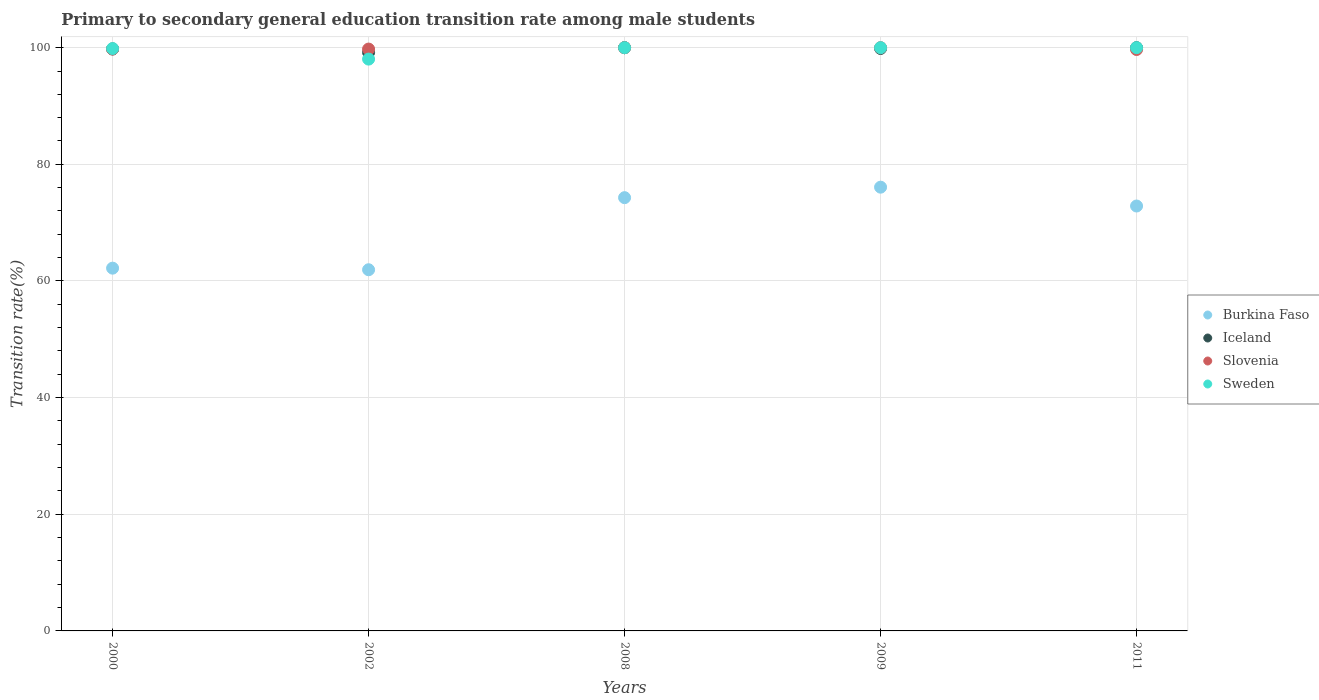How many different coloured dotlines are there?
Offer a very short reply. 4. What is the transition rate in Slovenia in 2002?
Give a very brief answer. 99.76. Across all years, what is the minimum transition rate in Iceland?
Make the answer very short. 99.18. In which year was the transition rate in Sweden maximum?
Give a very brief answer. 2008. What is the total transition rate in Burkina Faso in the graph?
Offer a terse response. 347.34. What is the difference between the transition rate in Slovenia in 2000 and that in 2002?
Offer a terse response. 0.01. What is the difference between the transition rate in Iceland in 2000 and the transition rate in Slovenia in 2008?
Offer a terse response. -0.23. What is the average transition rate in Burkina Faso per year?
Your answer should be very brief. 69.47. In the year 2008, what is the difference between the transition rate in Slovenia and transition rate in Sweden?
Ensure brevity in your answer.  0. What is the ratio of the transition rate in Sweden in 2000 to that in 2008?
Provide a short and direct response. 1. Is the difference between the transition rate in Slovenia in 2002 and 2011 greater than the difference between the transition rate in Sweden in 2002 and 2011?
Ensure brevity in your answer.  Yes. What is the difference between the highest and the second highest transition rate in Burkina Faso?
Ensure brevity in your answer.  1.8. What is the difference between the highest and the lowest transition rate in Sweden?
Your response must be concise. 1.96. Is the sum of the transition rate in Burkina Faso in 2000 and 2002 greater than the maximum transition rate in Sweden across all years?
Your response must be concise. Yes. Is it the case that in every year, the sum of the transition rate in Burkina Faso and transition rate in Slovenia  is greater than the transition rate in Iceland?
Ensure brevity in your answer.  Yes. Is the transition rate in Burkina Faso strictly greater than the transition rate in Sweden over the years?
Offer a very short reply. No. What is the difference between two consecutive major ticks on the Y-axis?
Provide a short and direct response. 20. Where does the legend appear in the graph?
Your answer should be very brief. Center right. How many legend labels are there?
Offer a terse response. 4. How are the legend labels stacked?
Offer a very short reply. Vertical. What is the title of the graph?
Your response must be concise. Primary to secondary general education transition rate among male students. What is the label or title of the X-axis?
Ensure brevity in your answer.  Years. What is the label or title of the Y-axis?
Offer a terse response. Transition rate(%). What is the Transition rate(%) of Burkina Faso in 2000?
Your answer should be compact. 62.2. What is the Transition rate(%) of Iceland in 2000?
Offer a very short reply. 99.77. What is the Transition rate(%) of Slovenia in 2000?
Offer a very short reply. 99.77. What is the Transition rate(%) of Sweden in 2000?
Make the answer very short. 99.85. What is the Transition rate(%) in Burkina Faso in 2002?
Your answer should be compact. 61.93. What is the Transition rate(%) in Iceland in 2002?
Make the answer very short. 99.18. What is the Transition rate(%) in Slovenia in 2002?
Ensure brevity in your answer.  99.76. What is the Transition rate(%) of Sweden in 2002?
Make the answer very short. 98.04. What is the Transition rate(%) of Burkina Faso in 2008?
Give a very brief answer. 74.28. What is the Transition rate(%) of Iceland in 2008?
Provide a short and direct response. 100. What is the Transition rate(%) in Sweden in 2008?
Keep it short and to the point. 100. What is the Transition rate(%) of Burkina Faso in 2009?
Your answer should be very brief. 76.08. What is the Transition rate(%) of Iceland in 2009?
Offer a terse response. 99.86. What is the Transition rate(%) of Slovenia in 2009?
Give a very brief answer. 100. What is the Transition rate(%) in Sweden in 2009?
Your answer should be very brief. 100. What is the Transition rate(%) in Burkina Faso in 2011?
Provide a short and direct response. 72.85. What is the Transition rate(%) in Slovenia in 2011?
Make the answer very short. 99.69. What is the Transition rate(%) of Sweden in 2011?
Provide a short and direct response. 100. Across all years, what is the maximum Transition rate(%) of Burkina Faso?
Give a very brief answer. 76.08. Across all years, what is the maximum Transition rate(%) of Iceland?
Keep it short and to the point. 100. Across all years, what is the maximum Transition rate(%) in Slovenia?
Give a very brief answer. 100. Across all years, what is the maximum Transition rate(%) in Sweden?
Give a very brief answer. 100. Across all years, what is the minimum Transition rate(%) of Burkina Faso?
Make the answer very short. 61.93. Across all years, what is the minimum Transition rate(%) of Iceland?
Provide a succinct answer. 99.18. Across all years, what is the minimum Transition rate(%) of Slovenia?
Offer a very short reply. 99.69. Across all years, what is the minimum Transition rate(%) in Sweden?
Keep it short and to the point. 98.04. What is the total Transition rate(%) in Burkina Faso in the graph?
Offer a very short reply. 347.34. What is the total Transition rate(%) in Iceland in the graph?
Your response must be concise. 498.81. What is the total Transition rate(%) of Slovenia in the graph?
Keep it short and to the point. 499.22. What is the total Transition rate(%) in Sweden in the graph?
Provide a short and direct response. 497.89. What is the difference between the Transition rate(%) in Burkina Faso in 2000 and that in 2002?
Make the answer very short. 0.27. What is the difference between the Transition rate(%) in Iceland in 2000 and that in 2002?
Your answer should be very brief. 0.59. What is the difference between the Transition rate(%) in Slovenia in 2000 and that in 2002?
Keep it short and to the point. 0.01. What is the difference between the Transition rate(%) in Sweden in 2000 and that in 2002?
Your answer should be compact. 1.81. What is the difference between the Transition rate(%) of Burkina Faso in 2000 and that in 2008?
Keep it short and to the point. -12.09. What is the difference between the Transition rate(%) of Iceland in 2000 and that in 2008?
Give a very brief answer. -0.23. What is the difference between the Transition rate(%) in Slovenia in 2000 and that in 2008?
Make the answer very short. -0.23. What is the difference between the Transition rate(%) of Sweden in 2000 and that in 2008?
Provide a succinct answer. -0.15. What is the difference between the Transition rate(%) of Burkina Faso in 2000 and that in 2009?
Offer a terse response. -13.88. What is the difference between the Transition rate(%) in Iceland in 2000 and that in 2009?
Make the answer very short. -0.09. What is the difference between the Transition rate(%) in Slovenia in 2000 and that in 2009?
Give a very brief answer. -0.23. What is the difference between the Transition rate(%) in Sweden in 2000 and that in 2009?
Make the answer very short. -0.15. What is the difference between the Transition rate(%) in Burkina Faso in 2000 and that in 2011?
Offer a very short reply. -10.65. What is the difference between the Transition rate(%) of Iceland in 2000 and that in 2011?
Ensure brevity in your answer.  -0.23. What is the difference between the Transition rate(%) in Slovenia in 2000 and that in 2011?
Offer a terse response. 0.09. What is the difference between the Transition rate(%) in Sweden in 2000 and that in 2011?
Offer a terse response. -0.15. What is the difference between the Transition rate(%) of Burkina Faso in 2002 and that in 2008?
Make the answer very short. -12.36. What is the difference between the Transition rate(%) of Iceland in 2002 and that in 2008?
Keep it short and to the point. -0.82. What is the difference between the Transition rate(%) in Slovenia in 2002 and that in 2008?
Offer a terse response. -0.24. What is the difference between the Transition rate(%) of Sweden in 2002 and that in 2008?
Offer a very short reply. -1.96. What is the difference between the Transition rate(%) in Burkina Faso in 2002 and that in 2009?
Offer a very short reply. -14.16. What is the difference between the Transition rate(%) of Iceland in 2002 and that in 2009?
Offer a terse response. -0.68. What is the difference between the Transition rate(%) of Slovenia in 2002 and that in 2009?
Your answer should be very brief. -0.24. What is the difference between the Transition rate(%) in Sweden in 2002 and that in 2009?
Your answer should be compact. -1.96. What is the difference between the Transition rate(%) of Burkina Faso in 2002 and that in 2011?
Your answer should be very brief. -10.93. What is the difference between the Transition rate(%) in Iceland in 2002 and that in 2011?
Ensure brevity in your answer.  -0.82. What is the difference between the Transition rate(%) of Slovenia in 2002 and that in 2011?
Provide a succinct answer. 0.07. What is the difference between the Transition rate(%) of Sweden in 2002 and that in 2011?
Your answer should be compact. -1.96. What is the difference between the Transition rate(%) in Burkina Faso in 2008 and that in 2009?
Keep it short and to the point. -1.8. What is the difference between the Transition rate(%) in Iceland in 2008 and that in 2009?
Ensure brevity in your answer.  0.14. What is the difference between the Transition rate(%) in Slovenia in 2008 and that in 2009?
Your answer should be very brief. 0. What is the difference between the Transition rate(%) of Sweden in 2008 and that in 2009?
Ensure brevity in your answer.  0. What is the difference between the Transition rate(%) in Burkina Faso in 2008 and that in 2011?
Provide a short and direct response. 1.43. What is the difference between the Transition rate(%) in Iceland in 2008 and that in 2011?
Your response must be concise. 0. What is the difference between the Transition rate(%) of Slovenia in 2008 and that in 2011?
Ensure brevity in your answer.  0.31. What is the difference between the Transition rate(%) in Burkina Faso in 2009 and that in 2011?
Give a very brief answer. 3.23. What is the difference between the Transition rate(%) in Iceland in 2009 and that in 2011?
Offer a terse response. -0.14. What is the difference between the Transition rate(%) of Slovenia in 2009 and that in 2011?
Your response must be concise. 0.31. What is the difference between the Transition rate(%) in Burkina Faso in 2000 and the Transition rate(%) in Iceland in 2002?
Give a very brief answer. -36.98. What is the difference between the Transition rate(%) of Burkina Faso in 2000 and the Transition rate(%) of Slovenia in 2002?
Provide a short and direct response. -37.56. What is the difference between the Transition rate(%) in Burkina Faso in 2000 and the Transition rate(%) in Sweden in 2002?
Make the answer very short. -35.84. What is the difference between the Transition rate(%) in Iceland in 2000 and the Transition rate(%) in Slovenia in 2002?
Your answer should be very brief. 0.01. What is the difference between the Transition rate(%) in Iceland in 2000 and the Transition rate(%) in Sweden in 2002?
Keep it short and to the point. 1.73. What is the difference between the Transition rate(%) in Slovenia in 2000 and the Transition rate(%) in Sweden in 2002?
Provide a short and direct response. 1.73. What is the difference between the Transition rate(%) of Burkina Faso in 2000 and the Transition rate(%) of Iceland in 2008?
Make the answer very short. -37.8. What is the difference between the Transition rate(%) in Burkina Faso in 2000 and the Transition rate(%) in Slovenia in 2008?
Offer a terse response. -37.8. What is the difference between the Transition rate(%) in Burkina Faso in 2000 and the Transition rate(%) in Sweden in 2008?
Offer a very short reply. -37.8. What is the difference between the Transition rate(%) in Iceland in 2000 and the Transition rate(%) in Slovenia in 2008?
Your answer should be very brief. -0.23. What is the difference between the Transition rate(%) of Iceland in 2000 and the Transition rate(%) of Sweden in 2008?
Keep it short and to the point. -0.23. What is the difference between the Transition rate(%) in Slovenia in 2000 and the Transition rate(%) in Sweden in 2008?
Keep it short and to the point. -0.23. What is the difference between the Transition rate(%) in Burkina Faso in 2000 and the Transition rate(%) in Iceland in 2009?
Provide a succinct answer. -37.66. What is the difference between the Transition rate(%) of Burkina Faso in 2000 and the Transition rate(%) of Slovenia in 2009?
Provide a short and direct response. -37.8. What is the difference between the Transition rate(%) in Burkina Faso in 2000 and the Transition rate(%) in Sweden in 2009?
Provide a succinct answer. -37.8. What is the difference between the Transition rate(%) in Iceland in 2000 and the Transition rate(%) in Slovenia in 2009?
Provide a short and direct response. -0.23. What is the difference between the Transition rate(%) in Iceland in 2000 and the Transition rate(%) in Sweden in 2009?
Provide a succinct answer. -0.23. What is the difference between the Transition rate(%) in Slovenia in 2000 and the Transition rate(%) in Sweden in 2009?
Keep it short and to the point. -0.23. What is the difference between the Transition rate(%) in Burkina Faso in 2000 and the Transition rate(%) in Iceland in 2011?
Your response must be concise. -37.8. What is the difference between the Transition rate(%) of Burkina Faso in 2000 and the Transition rate(%) of Slovenia in 2011?
Your response must be concise. -37.49. What is the difference between the Transition rate(%) in Burkina Faso in 2000 and the Transition rate(%) in Sweden in 2011?
Your response must be concise. -37.8. What is the difference between the Transition rate(%) of Iceland in 2000 and the Transition rate(%) of Slovenia in 2011?
Make the answer very short. 0.09. What is the difference between the Transition rate(%) of Iceland in 2000 and the Transition rate(%) of Sweden in 2011?
Your response must be concise. -0.23. What is the difference between the Transition rate(%) of Slovenia in 2000 and the Transition rate(%) of Sweden in 2011?
Give a very brief answer. -0.23. What is the difference between the Transition rate(%) of Burkina Faso in 2002 and the Transition rate(%) of Iceland in 2008?
Your answer should be very brief. -38.07. What is the difference between the Transition rate(%) in Burkina Faso in 2002 and the Transition rate(%) in Slovenia in 2008?
Offer a very short reply. -38.07. What is the difference between the Transition rate(%) in Burkina Faso in 2002 and the Transition rate(%) in Sweden in 2008?
Give a very brief answer. -38.07. What is the difference between the Transition rate(%) of Iceland in 2002 and the Transition rate(%) of Slovenia in 2008?
Make the answer very short. -0.82. What is the difference between the Transition rate(%) in Iceland in 2002 and the Transition rate(%) in Sweden in 2008?
Ensure brevity in your answer.  -0.82. What is the difference between the Transition rate(%) of Slovenia in 2002 and the Transition rate(%) of Sweden in 2008?
Your answer should be very brief. -0.24. What is the difference between the Transition rate(%) in Burkina Faso in 2002 and the Transition rate(%) in Iceland in 2009?
Give a very brief answer. -37.94. What is the difference between the Transition rate(%) of Burkina Faso in 2002 and the Transition rate(%) of Slovenia in 2009?
Offer a terse response. -38.07. What is the difference between the Transition rate(%) in Burkina Faso in 2002 and the Transition rate(%) in Sweden in 2009?
Your response must be concise. -38.07. What is the difference between the Transition rate(%) in Iceland in 2002 and the Transition rate(%) in Slovenia in 2009?
Keep it short and to the point. -0.82. What is the difference between the Transition rate(%) of Iceland in 2002 and the Transition rate(%) of Sweden in 2009?
Your response must be concise. -0.82. What is the difference between the Transition rate(%) in Slovenia in 2002 and the Transition rate(%) in Sweden in 2009?
Your answer should be very brief. -0.24. What is the difference between the Transition rate(%) of Burkina Faso in 2002 and the Transition rate(%) of Iceland in 2011?
Offer a terse response. -38.07. What is the difference between the Transition rate(%) in Burkina Faso in 2002 and the Transition rate(%) in Slovenia in 2011?
Offer a very short reply. -37.76. What is the difference between the Transition rate(%) of Burkina Faso in 2002 and the Transition rate(%) of Sweden in 2011?
Offer a very short reply. -38.07. What is the difference between the Transition rate(%) of Iceland in 2002 and the Transition rate(%) of Slovenia in 2011?
Your answer should be compact. -0.51. What is the difference between the Transition rate(%) of Iceland in 2002 and the Transition rate(%) of Sweden in 2011?
Offer a terse response. -0.82. What is the difference between the Transition rate(%) in Slovenia in 2002 and the Transition rate(%) in Sweden in 2011?
Offer a terse response. -0.24. What is the difference between the Transition rate(%) in Burkina Faso in 2008 and the Transition rate(%) in Iceland in 2009?
Provide a short and direct response. -25.58. What is the difference between the Transition rate(%) of Burkina Faso in 2008 and the Transition rate(%) of Slovenia in 2009?
Provide a short and direct response. -25.72. What is the difference between the Transition rate(%) of Burkina Faso in 2008 and the Transition rate(%) of Sweden in 2009?
Make the answer very short. -25.72. What is the difference between the Transition rate(%) of Iceland in 2008 and the Transition rate(%) of Sweden in 2009?
Offer a terse response. 0. What is the difference between the Transition rate(%) of Burkina Faso in 2008 and the Transition rate(%) of Iceland in 2011?
Your answer should be very brief. -25.72. What is the difference between the Transition rate(%) in Burkina Faso in 2008 and the Transition rate(%) in Slovenia in 2011?
Make the answer very short. -25.4. What is the difference between the Transition rate(%) of Burkina Faso in 2008 and the Transition rate(%) of Sweden in 2011?
Provide a succinct answer. -25.72. What is the difference between the Transition rate(%) in Iceland in 2008 and the Transition rate(%) in Slovenia in 2011?
Keep it short and to the point. 0.31. What is the difference between the Transition rate(%) of Iceland in 2008 and the Transition rate(%) of Sweden in 2011?
Your answer should be compact. 0. What is the difference between the Transition rate(%) in Slovenia in 2008 and the Transition rate(%) in Sweden in 2011?
Your answer should be very brief. 0. What is the difference between the Transition rate(%) of Burkina Faso in 2009 and the Transition rate(%) of Iceland in 2011?
Ensure brevity in your answer.  -23.92. What is the difference between the Transition rate(%) of Burkina Faso in 2009 and the Transition rate(%) of Slovenia in 2011?
Ensure brevity in your answer.  -23.6. What is the difference between the Transition rate(%) in Burkina Faso in 2009 and the Transition rate(%) in Sweden in 2011?
Your response must be concise. -23.92. What is the difference between the Transition rate(%) of Iceland in 2009 and the Transition rate(%) of Slovenia in 2011?
Offer a very short reply. 0.17. What is the difference between the Transition rate(%) in Iceland in 2009 and the Transition rate(%) in Sweden in 2011?
Your response must be concise. -0.14. What is the average Transition rate(%) of Burkina Faso per year?
Your response must be concise. 69.47. What is the average Transition rate(%) of Iceland per year?
Give a very brief answer. 99.76. What is the average Transition rate(%) of Slovenia per year?
Ensure brevity in your answer.  99.84. What is the average Transition rate(%) in Sweden per year?
Your response must be concise. 99.58. In the year 2000, what is the difference between the Transition rate(%) in Burkina Faso and Transition rate(%) in Iceland?
Ensure brevity in your answer.  -37.57. In the year 2000, what is the difference between the Transition rate(%) of Burkina Faso and Transition rate(%) of Slovenia?
Make the answer very short. -37.58. In the year 2000, what is the difference between the Transition rate(%) in Burkina Faso and Transition rate(%) in Sweden?
Make the answer very short. -37.65. In the year 2000, what is the difference between the Transition rate(%) of Iceland and Transition rate(%) of Slovenia?
Provide a succinct answer. -0. In the year 2000, what is the difference between the Transition rate(%) of Iceland and Transition rate(%) of Sweden?
Offer a terse response. -0.08. In the year 2000, what is the difference between the Transition rate(%) in Slovenia and Transition rate(%) in Sweden?
Your response must be concise. -0.08. In the year 2002, what is the difference between the Transition rate(%) in Burkina Faso and Transition rate(%) in Iceland?
Offer a terse response. -37.25. In the year 2002, what is the difference between the Transition rate(%) in Burkina Faso and Transition rate(%) in Slovenia?
Offer a terse response. -37.84. In the year 2002, what is the difference between the Transition rate(%) of Burkina Faso and Transition rate(%) of Sweden?
Provide a succinct answer. -36.12. In the year 2002, what is the difference between the Transition rate(%) of Iceland and Transition rate(%) of Slovenia?
Your response must be concise. -0.58. In the year 2002, what is the difference between the Transition rate(%) in Iceland and Transition rate(%) in Sweden?
Ensure brevity in your answer.  1.14. In the year 2002, what is the difference between the Transition rate(%) in Slovenia and Transition rate(%) in Sweden?
Your answer should be compact. 1.72. In the year 2008, what is the difference between the Transition rate(%) of Burkina Faso and Transition rate(%) of Iceland?
Provide a short and direct response. -25.72. In the year 2008, what is the difference between the Transition rate(%) of Burkina Faso and Transition rate(%) of Slovenia?
Make the answer very short. -25.72. In the year 2008, what is the difference between the Transition rate(%) in Burkina Faso and Transition rate(%) in Sweden?
Provide a succinct answer. -25.72. In the year 2008, what is the difference between the Transition rate(%) of Iceland and Transition rate(%) of Slovenia?
Give a very brief answer. 0. In the year 2008, what is the difference between the Transition rate(%) in Iceland and Transition rate(%) in Sweden?
Ensure brevity in your answer.  0. In the year 2009, what is the difference between the Transition rate(%) in Burkina Faso and Transition rate(%) in Iceland?
Provide a short and direct response. -23.78. In the year 2009, what is the difference between the Transition rate(%) in Burkina Faso and Transition rate(%) in Slovenia?
Your answer should be compact. -23.92. In the year 2009, what is the difference between the Transition rate(%) of Burkina Faso and Transition rate(%) of Sweden?
Make the answer very short. -23.92. In the year 2009, what is the difference between the Transition rate(%) in Iceland and Transition rate(%) in Slovenia?
Offer a very short reply. -0.14. In the year 2009, what is the difference between the Transition rate(%) in Iceland and Transition rate(%) in Sweden?
Provide a succinct answer. -0.14. In the year 2009, what is the difference between the Transition rate(%) in Slovenia and Transition rate(%) in Sweden?
Provide a succinct answer. 0. In the year 2011, what is the difference between the Transition rate(%) in Burkina Faso and Transition rate(%) in Iceland?
Your response must be concise. -27.15. In the year 2011, what is the difference between the Transition rate(%) in Burkina Faso and Transition rate(%) in Slovenia?
Provide a short and direct response. -26.83. In the year 2011, what is the difference between the Transition rate(%) in Burkina Faso and Transition rate(%) in Sweden?
Your answer should be very brief. -27.15. In the year 2011, what is the difference between the Transition rate(%) in Iceland and Transition rate(%) in Slovenia?
Ensure brevity in your answer.  0.31. In the year 2011, what is the difference between the Transition rate(%) in Iceland and Transition rate(%) in Sweden?
Offer a very short reply. 0. In the year 2011, what is the difference between the Transition rate(%) in Slovenia and Transition rate(%) in Sweden?
Ensure brevity in your answer.  -0.31. What is the ratio of the Transition rate(%) of Iceland in 2000 to that in 2002?
Provide a succinct answer. 1.01. What is the ratio of the Transition rate(%) of Sweden in 2000 to that in 2002?
Offer a terse response. 1.02. What is the ratio of the Transition rate(%) of Burkina Faso in 2000 to that in 2008?
Offer a terse response. 0.84. What is the ratio of the Transition rate(%) of Iceland in 2000 to that in 2008?
Keep it short and to the point. 1. What is the ratio of the Transition rate(%) in Burkina Faso in 2000 to that in 2009?
Provide a short and direct response. 0.82. What is the ratio of the Transition rate(%) in Iceland in 2000 to that in 2009?
Offer a terse response. 1. What is the ratio of the Transition rate(%) in Slovenia in 2000 to that in 2009?
Your response must be concise. 1. What is the ratio of the Transition rate(%) in Burkina Faso in 2000 to that in 2011?
Provide a succinct answer. 0.85. What is the ratio of the Transition rate(%) in Iceland in 2000 to that in 2011?
Offer a terse response. 1. What is the ratio of the Transition rate(%) in Burkina Faso in 2002 to that in 2008?
Your response must be concise. 0.83. What is the ratio of the Transition rate(%) of Sweden in 2002 to that in 2008?
Make the answer very short. 0.98. What is the ratio of the Transition rate(%) of Burkina Faso in 2002 to that in 2009?
Provide a succinct answer. 0.81. What is the ratio of the Transition rate(%) of Sweden in 2002 to that in 2009?
Make the answer very short. 0.98. What is the ratio of the Transition rate(%) in Burkina Faso in 2002 to that in 2011?
Provide a short and direct response. 0.85. What is the ratio of the Transition rate(%) in Sweden in 2002 to that in 2011?
Offer a very short reply. 0.98. What is the ratio of the Transition rate(%) of Burkina Faso in 2008 to that in 2009?
Offer a terse response. 0.98. What is the ratio of the Transition rate(%) of Iceland in 2008 to that in 2009?
Keep it short and to the point. 1. What is the ratio of the Transition rate(%) of Sweden in 2008 to that in 2009?
Your answer should be very brief. 1. What is the ratio of the Transition rate(%) of Burkina Faso in 2008 to that in 2011?
Give a very brief answer. 1.02. What is the ratio of the Transition rate(%) of Slovenia in 2008 to that in 2011?
Provide a short and direct response. 1. What is the ratio of the Transition rate(%) in Burkina Faso in 2009 to that in 2011?
Make the answer very short. 1.04. What is the ratio of the Transition rate(%) of Sweden in 2009 to that in 2011?
Make the answer very short. 1. What is the difference between the highest and the second highest Transition rate(%) in Burkina Faso?
Provide a short and direct response. 1.8. What is the difference between the highest and the second highest Transition rate(%) in Slovenia?
Offer a very short reply. 0. What is the difference between the highest and the second highest Transition rate(%) of Sweden?
Offer a terse response. 0. What is the difference between the highest and the lowest Transition rate(%) in Burkina Faso?
Your answer should be compact. 14.16. What is the difference between the highest and the lowest Transition rate(%) in Iceland?
Your answer should be compact. 0.82. What is the difference between the highest and the lowest Transition rate(%) of Slovenia?
Provide a short and direct response. 0.31. What is the difference between the highest and the lowest Transition rate(%) in Sweden?
Provide a short and direct response. 1.96. 